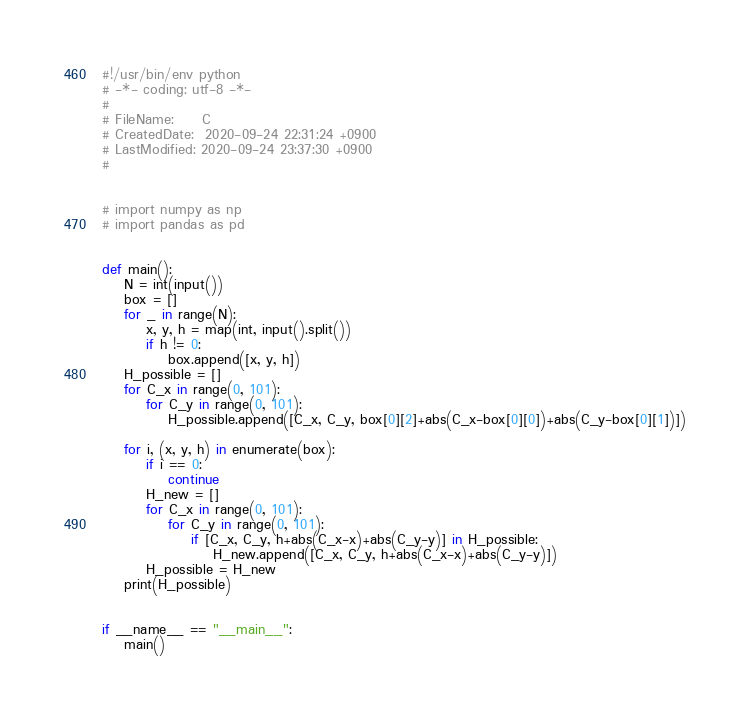Convert code to text. <code><loc_0><loc_0><loc_500><loc_500><_Python_>#!/usr/bin/env python
# -*- coding: utf-8 -*-
#
# FileName: 	C
# CreatedDate:  2020-09-24 22:31:24 +0900
# LastModified: 2020-09-24 23:37:30 +0900
#


# import numpy as np
# import pandas as pd


def main():
    N = int(input())
    box = []
    for _ in range(N):
        x, y, h = map(int, input().split())
        if h != 0:
            box.append([x, y, h])
    H_possible = []
    for C_x in range(0, 101):
        for C_y in range(0, 101):
            H_possible.append([C_x, C_y, box[0][2]+abs(C_x-box[0][0])+abs(C_y-box[0][1])])

    for i, (x, y, h) in enumerate(box):
        if i == 0:
            continue
        H_new = []
        for C_x in range(0, 101):
            for C_y in range(0, 101):
                if [C_x, C_y, h+abs(C_x-x)+abs(C_y-y)] in H_possible:
                    H_new.append([C_x, C_y, h+abs(C_x-x)+abs(C_y-y)])
        H_possible = H_new
    print(H_possible)


if __name__ == "__main__":
    main()
</code> 